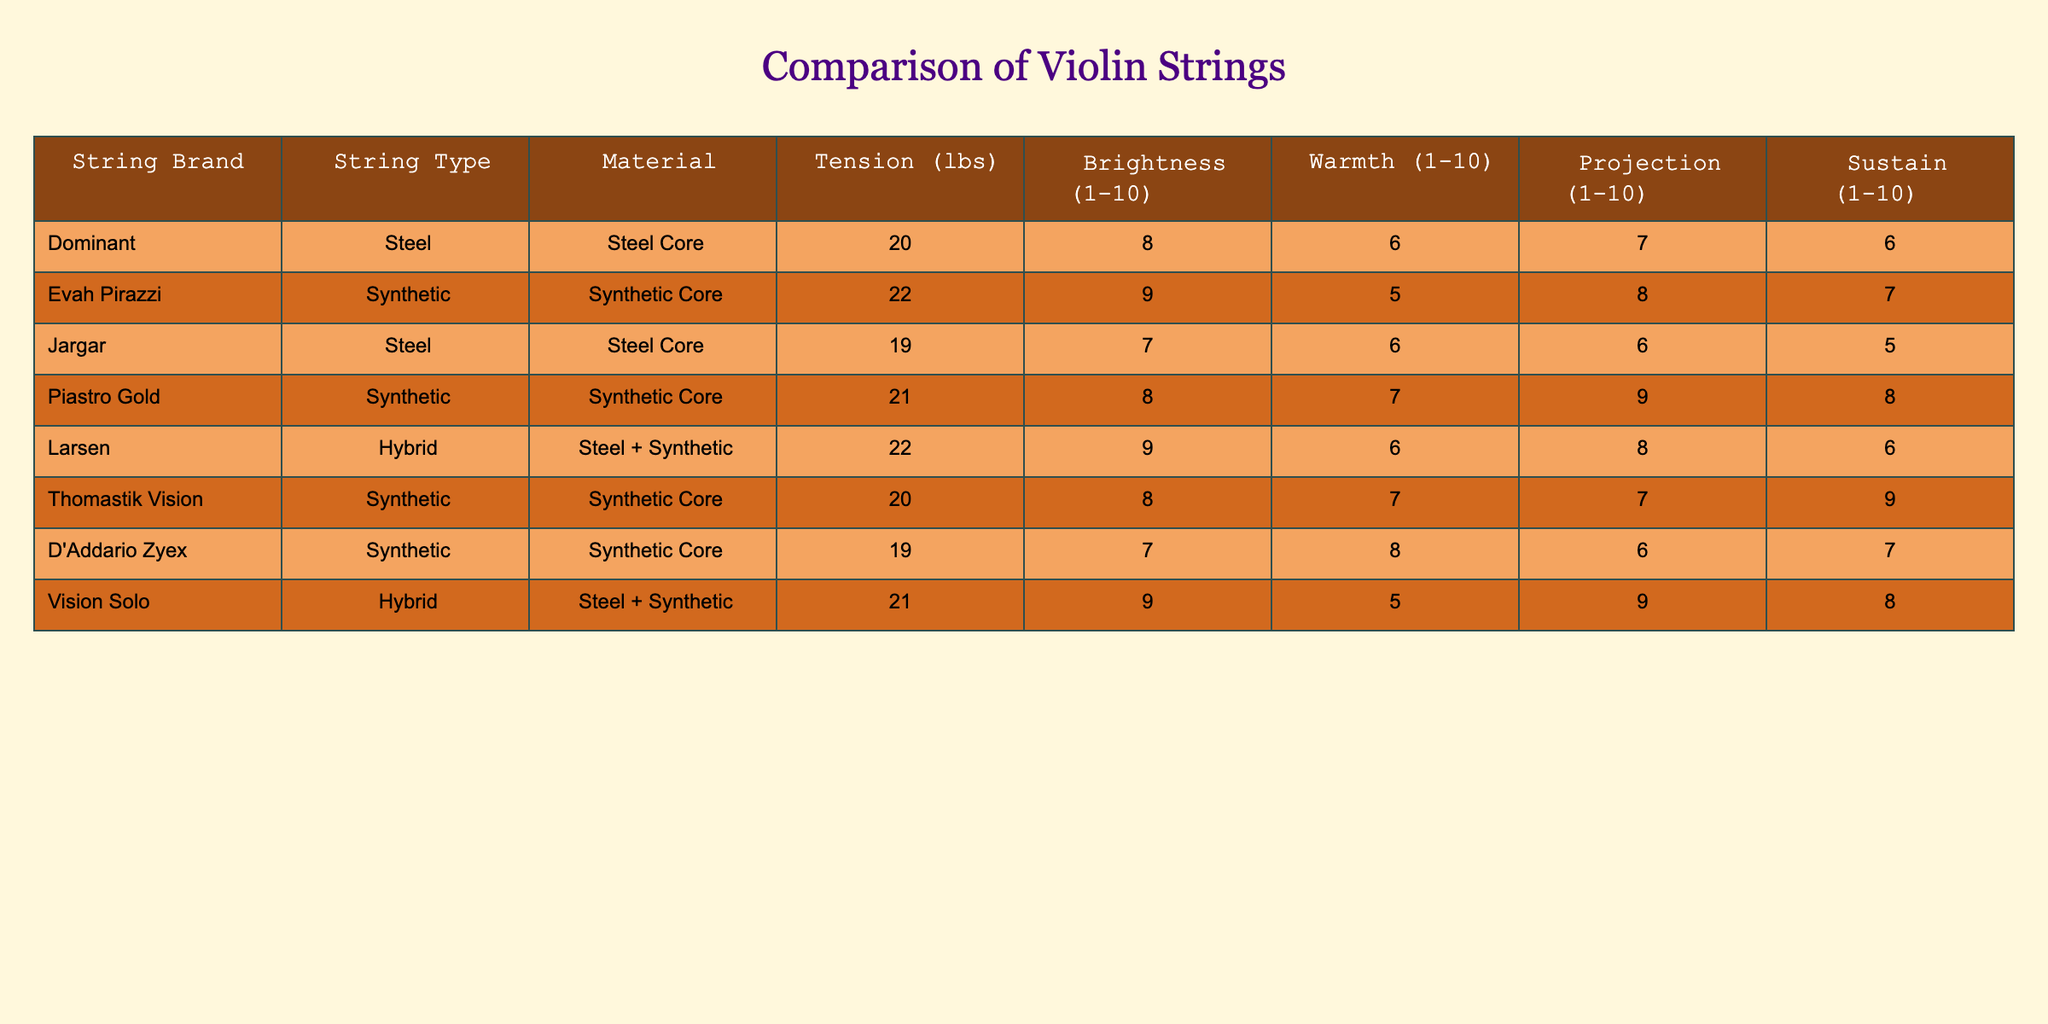What is the brightness value of the Evah Pirazzi string? According to the table, the Evah Pirazzi string has a brightness value listed under the "Brightness" column. This value is 9.
Answer: 9 Which string type has the highest warmth score? By examining the "Warmth" column in the table, the string type with the highest warmth score is the D'Addario Zyex string, which has a score of 8.
Answer: D'Addario Zyex What is the average projection score of all synthetic strings? First, we identify the synthetic strings from the table: Evah Pirazzi (8), Piastro Gold (9), Thomastik Vision (7), and D'Addario Zyex (6). The sum of their projection scores is 8 + 9 + 7 + 6 = 30. There are 4 synthetic strings, so the average projection score is 30 / 4 = 7.5.
Answer: 7.5 Is the warmth score of any hybrid strings greater than or equal to 7? We check the warmth scores of the hybrid strings: Larsen has a score of 6 and Vision Solo has a score of 5. Since both scores are less than 7, the answer is no.
Answer: No Which string has the highest sustain score and what is that score? Looking at the "Sustain" column, we can see that the Thomastik Vision string has the highest sustain score, which is 9.
Answer: Thomastik Vision, 9 What is the difference in tension (in lbs) between the string with the highest and the string with the lowest tension? The highest tension is 22 lbs (for Evah Pirazzi and Larsen), and the lowest tension is 19 lbs (for Jargar and D'Addario Zyex). The difference is 22 - 19 = 3 lbs.
Answer: 3 lbs Which synthetic string has the best combination of brightness and sustain based on the scores? From the synthetic strings, Evah Pirazzi has a brightness of 9 and sustain of 7, Piastro Gold has brightness of 8 and sustain of 8, Thomastik Vision has brightness of 8 and sustain of 9, D'Addario Zyex has brightness of 7 and sustain of 7. The best combination is Thomastik Vision with a brightness of 8 and a sustain of 9.
Answer: Thomastik Vision Are there more steel core strings or synthetic core strings in the table? We count the strings: there are 3 steel core strings (Dominant, Jargar, and Vision Solo) and 5 synthetic core strings (Evah Pirazzi, Piastro Gold, Thomastik Vision, D'Addario Zyex). Therefore, there are more synthetic core strings.
Answer: Yes, synthetic core strings are more 